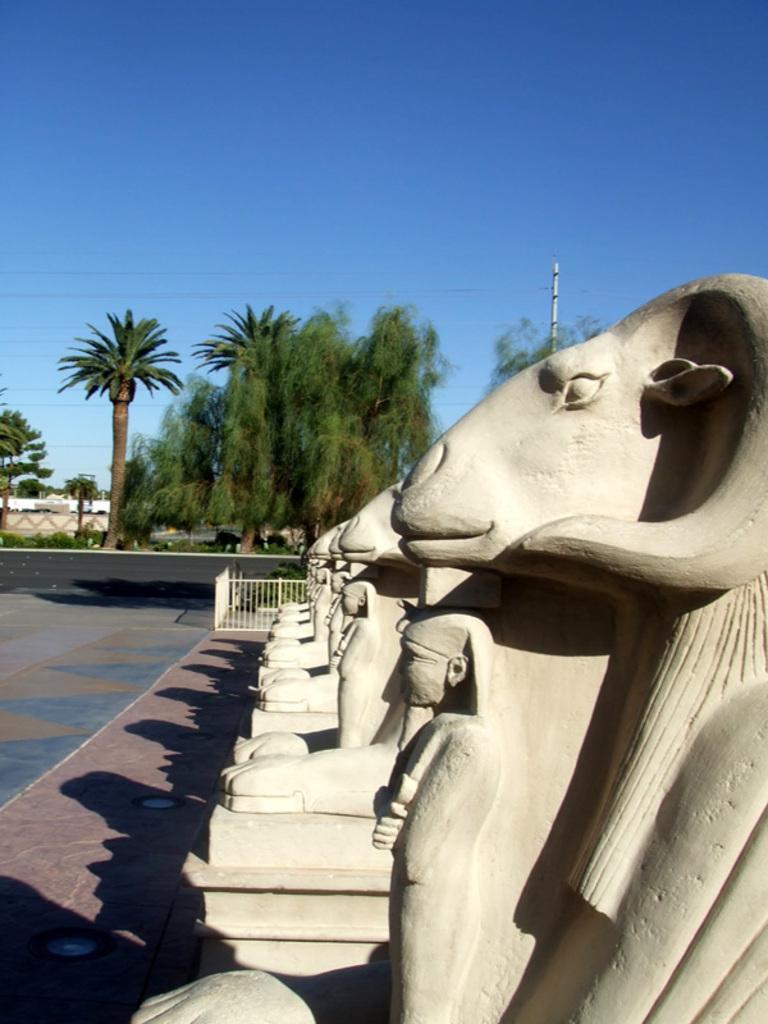Please provide a concise description of this image. In the picture there are few sculptures and behind the sculptures there are many tall trees, there is a path in front of the sculptures. In the background there is a sky. 